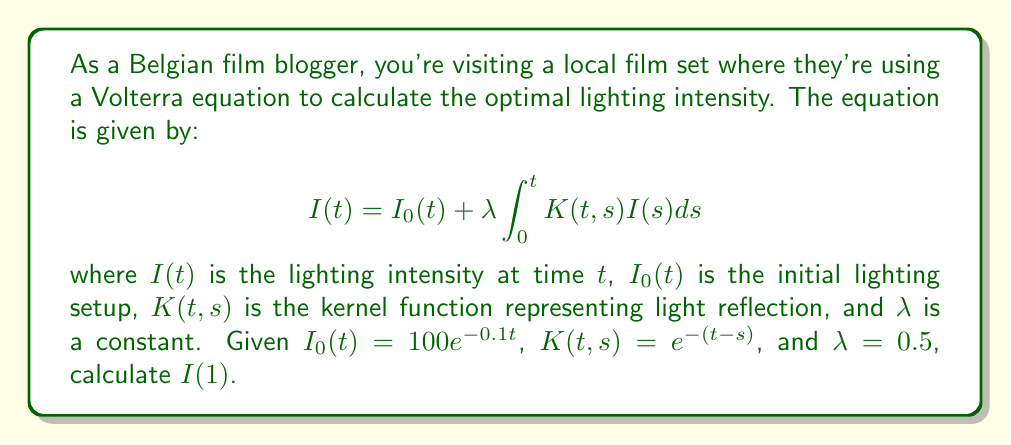What is the answer to this math problem? To solve this Volterra equation, we'll use the method of successive approximations:

1) Start with the initial approximation $I_0(t) = 100e^{-0.1t}$

2) Calculate the next approximation:
   $$I_1(t) = 100e^{-0.1t} + 0.5 \int_0^t e^{-(t-s)}100e^{-0.1s}ds$$

3) Evaluate the integral:
   $$\begin{align}
   I_1(t) &= 100e^{-0.1t} + 50 \int_0^t e^{-t+s}e^{-0.1s}ds \\
   &= 100e^{-0.1t} + 50e^{-t} \int_0^t e^{0.9s}ds \\
   &= 100e^{-0.1t} + 50e^{-t} \cdot \frac{1}{0.9}(e^{0.9t} - 1) \\
   &= 100e^{-0.1t} + \frac{50}{0.9}(1 - e^{-0.9t})
   \end{align}$$

4) For $t = 1$:
   $$\begin{align}
   I_1(1) &= 100e^{-0.1} + \frac{50}{0.9}(1 - e^{-0.9}) \\
   &\approx 90.48 + 38.39 \\
   &\approx 128.87
   \end{align}$$

This approximation is usually close enough for practical purposes. For higher accuracy, we could continue the iteration process.
Answer: $I(1) \approx 128.87$ 